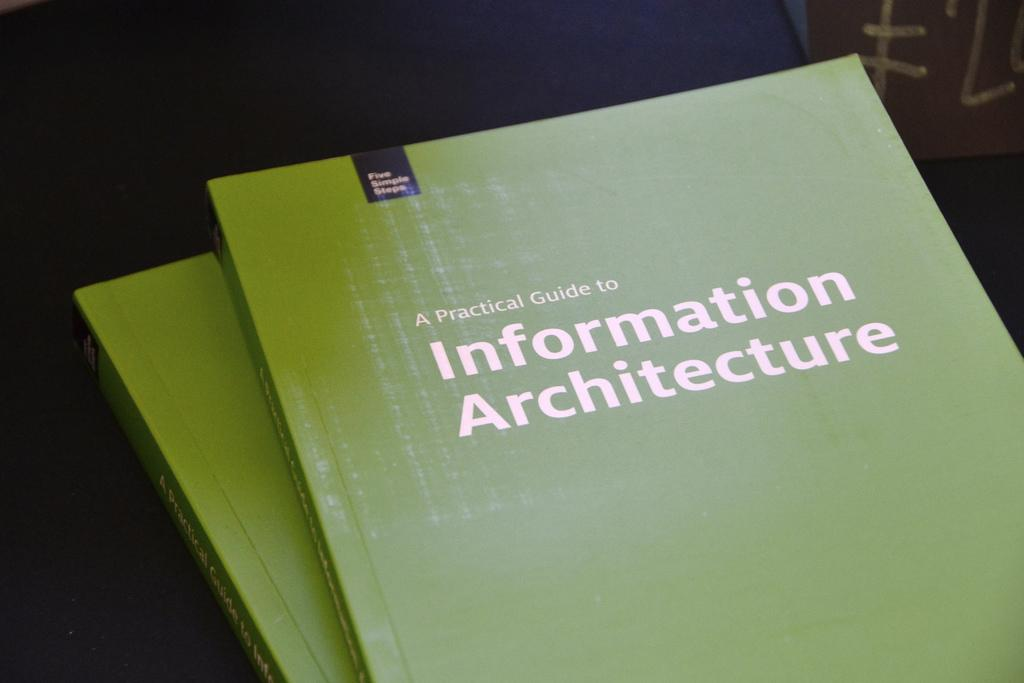What type of objects can be seen in the image? There are books in the image. Can you describe the books in the image? The books are likely made of paper and have covers and pages. How many books are visible in the image? The number of books cannot be determined from the provided facts. What type of bit is being used by the visitor in the image? There is no visitor or bit present in the image; it only features books. 